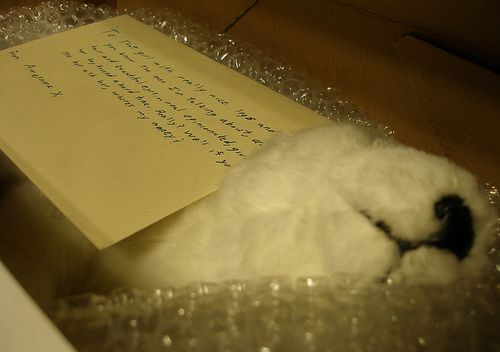<image>
Can you confirm if the note is in front of the dog? No. The note is not in front of the dog. The spatial positioning shows a different relationship between these objects. 